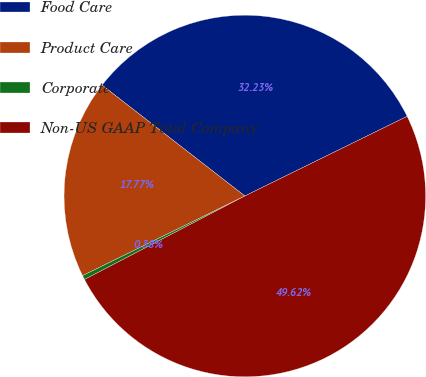Convert chart to OTSL. <chart><loc_0><loc_0><loc_500><loc_500><pie_chart><fcel>Food Care<fcel>Product Care<fcel>Corporate<fcel>Non-US GAAP Total Company<nl><fcel>32.23%<fcel>17.77%<fcel>0.38%<fcel>49.62%<nl></chart> 